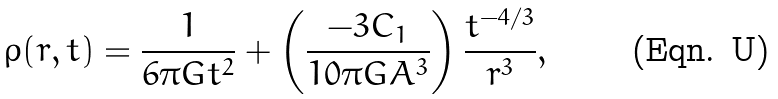<formula> <loc_0><loc_0><loc_500><loc_500>\rho ( r , t ) = \frac { 1 } { 6 \pi G t ^ { 2 } } + \left ( \frac { - 3 C _ { 1 } } { 1 0 \pi G A ^ { 3 } } \right ) \frac { t ^ { - 4 / 3 } } { r ^ { 3 } } ,</formula> 